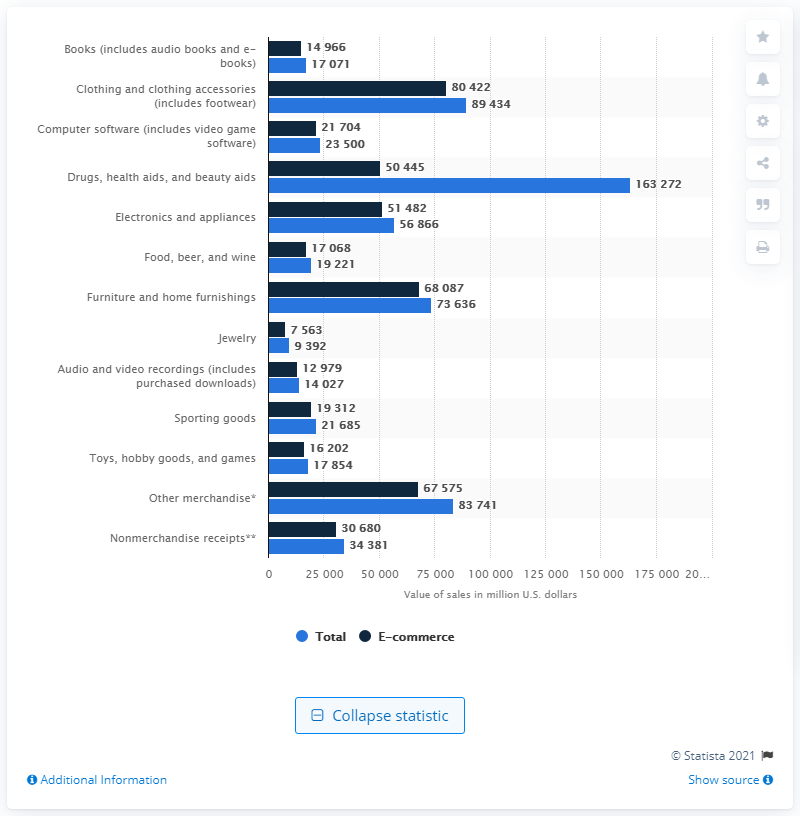Draw attention to some important aspects in this diagram. In 2019, the e-commerce sales of computer software were worth approximately 23,500 dollars. In 2019, the e-commerce sales of computer software were valued at approximately 23,500 dollars. 